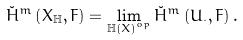<formula> <loc_0><loc_0><loc_500><loc_500>\check { H } ^ { m } \left ( X _ { \mathbb { H } } , F \right ) = \lim _ { \mathbb { H } \left ( X \right ) ^ { o p } } \check { H } ^ { m } \left ( U _ { \cdot } , F \right ) .</formula> 